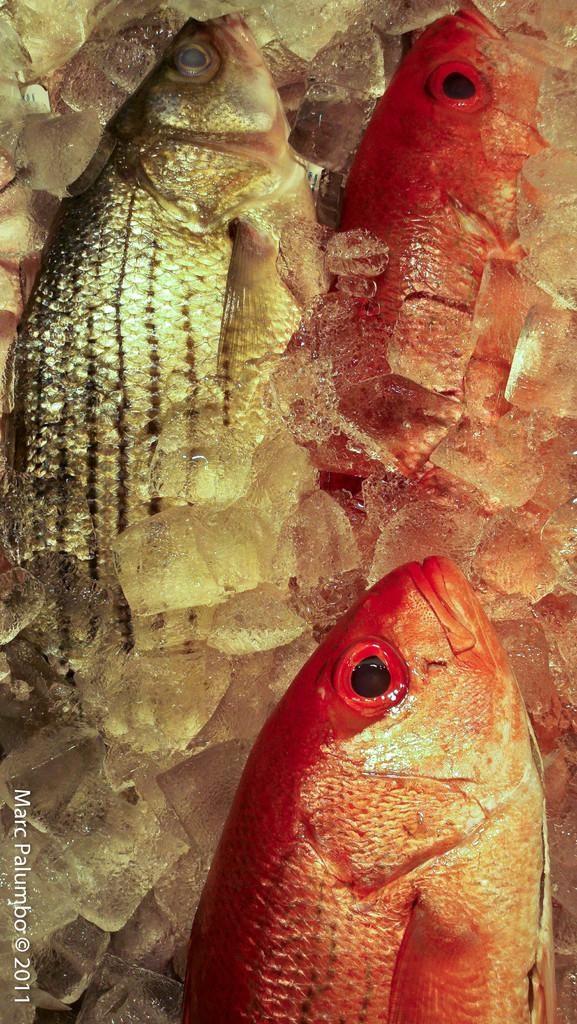How many fishes can be seen in the image? There are three fishes in the image. What else is present in the image besides the fishes? There are ice cubes in the image. Is there any text visible in the image? Yes, there is some text in the bottom left corner of the image. What type of lettuce is being served on the table in the image? There is no table or lettuce present in the image; it features three fishes and ice cubes. How many chickens are visible in the image? There are no chickens present in the image. 